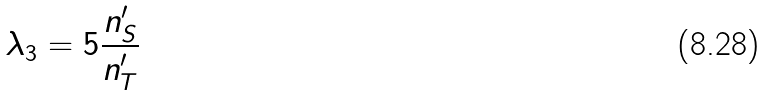<formula> <loc_0><loc_0><loc_500><loc_500>\lambda _ { 3 } = 5 \frac { n ^ { \prime } _ { S } } { n ^ { \prime } _ { T } }</formula> 